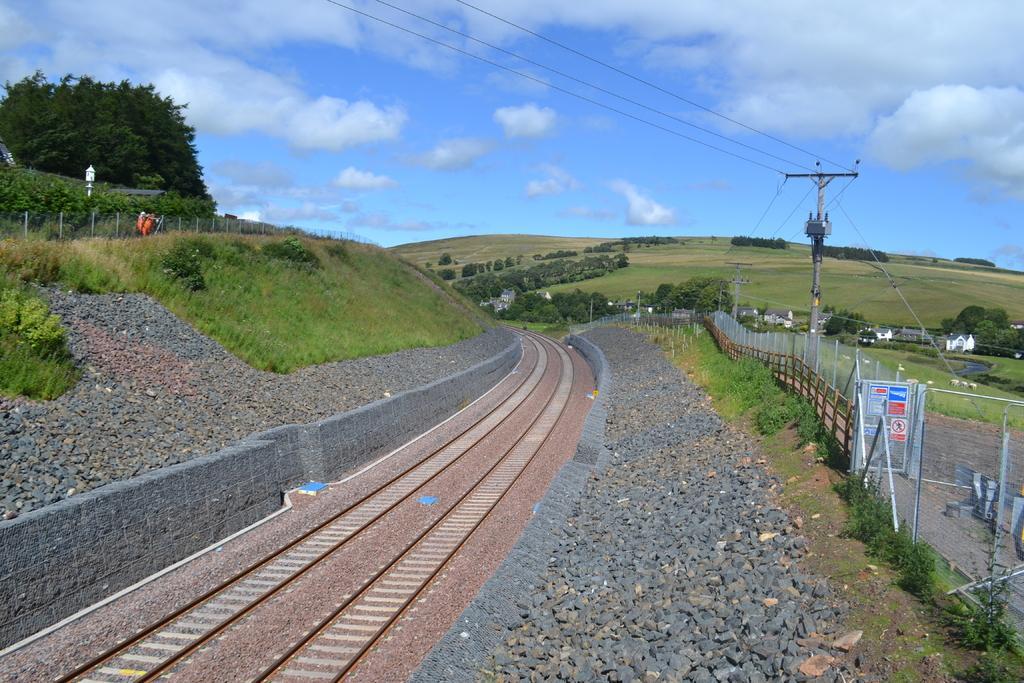Please provide a concise description of this image. In this image we can see railway tracks. On the ground there are stones. Also there is grass. On the right side there are railings. Also there is an electric pole with wires. And there are trees. In the background there is sky with clouds. 